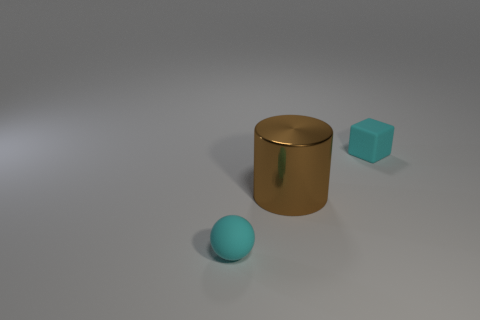Add 2 large things. How many objects exist? 5 Subtract all cylinders. How many objects are left? 2 Subtract 1 balls. How many balls are left? 0 Subtract 0 green spheres. How many objects are left? 3 Subtract all red cylinders. How many gray blocks are left? 0 Subtract all small spheres. Subtract all balls. How many objects are left? 1 Add 3 brown things. How many brown things are left? 4 Add 1 big yellow balls. How many big yellow balls exist? 1 